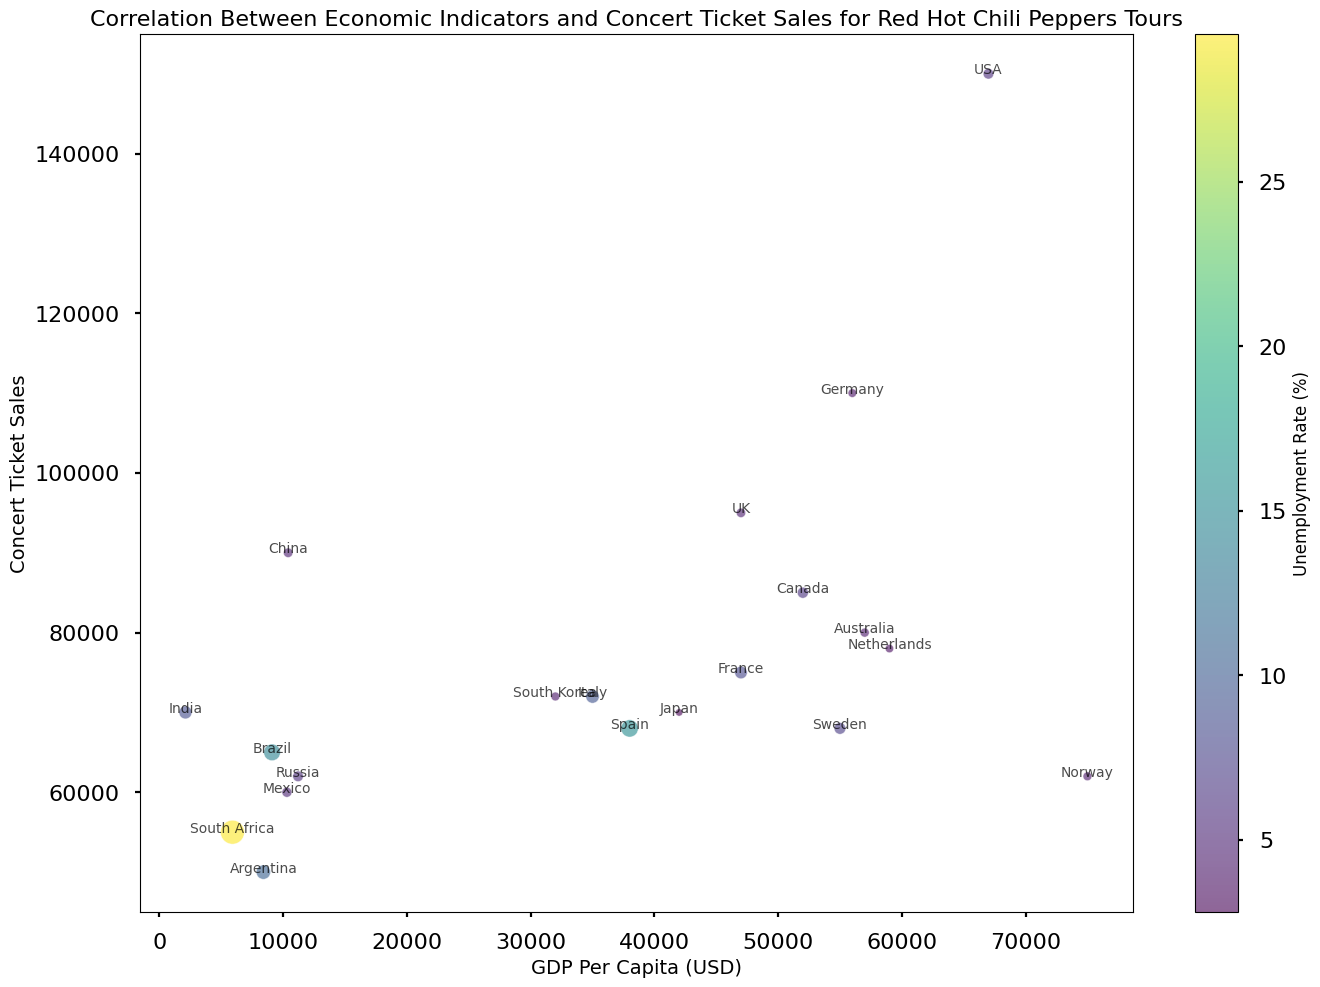What's the relationship between GDP Per Capita and Concert Ticket Sales for Red Hot Chili Peppers Tours? To understand the relationship, we can observe the scatter plot. Generally, a higher GDP Per Capita correlates with higher Concert Ticket Sales, indicating a positive correlation. The countries with higher GDP Per Capita like USA ($67,000) and Germany ($56,000) tend to have higher ticket sales.
Answer: Positive correlation Which country has the highest GDP Per Capita, and how many concert tickets were sold there? From the scatter plot, the USA has the highest GDP Per Capita at $67,000. The number of concert tickets sold there is around 150,000.
Answer: USA, 150,000 Which country has the highest unemployment rate and what are its Concert Ticket Sales? South Africa has the highest unemployment rate at 29.5%. The Concert Ticket Sales for Red Hot Chili Peppers Tours in South Africa are around 55,000.
Answer: South Africa, 55,000 How do the Concert Ticket Sales compare between Brazil and Russia? To compare, we look at the plotted points for Brazil and Russia. Brazil has around 65,000 ticket sales, while Russia has around 62,000 ticket sales. Therefore, Brazil has slightly higher concert ticket sales than Russia.
Answer: Brazil has higher sales Which country has a GDP Per Capita closest to $50,000, and what is its Unemployment Rate? By observing the scatter plot, Canada and UK have GDP Per Capita closest to $50,000 (Canada: $52,000, UK: $47,000). The Unemployment Rates are 6.3% for Canada and 4.5% for the UK.
Answer: Canada (6.3%) or UK (4.5%) Calculate the average Concert Ticket Sales for the countries with GDP Per Capita below $20,000. The countries with GDP Per Capita below $20,000 are Brazil, Argentina, Mexico, Russia, South Africa, India, and China. The corresponding ticket sales are 65,000, 50,000, 60,000, 62,000, 55,000, 70,000, and 90,000 respectively. The total is 452,000, and there are 7 countries, so the average is 452,000 / 7 ≈ 64,571.
Answer: 64,571 What is the color that represents an Unemployment Rate around 10% and which countries fall within this color range? In the scatter plot, the colormap indicates that around 10% Unemployment Rate is represented by a yellowish color. The countries falling within this range include Argentina (10.6%) and Italy (9.3%).
Answer: Yellowish, Argentina and Italy 